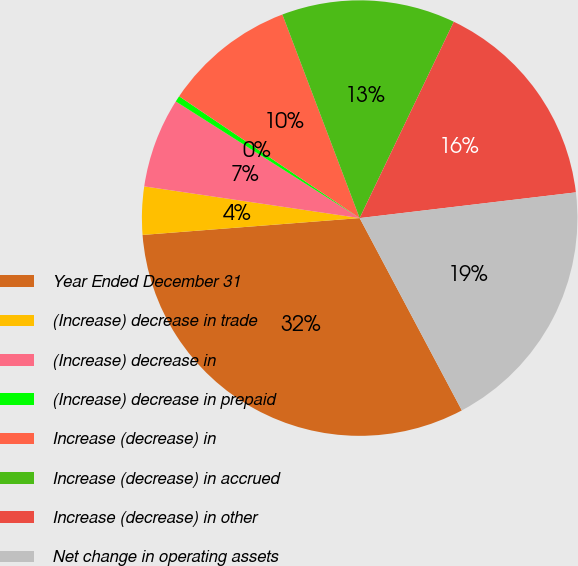Convert chart. <chart><loc_0><loc_0><loc_500><loc_500><pie_chart><fcel>Year Ended December 31<fcel>(Increase) decrease in trade<fcel>(Increase) decrease in<fcel>(Increase) decrease in prepaid<fcel>Increase (decrease) in<fcel>Increase (decrease) in accrued<fcel>Increase (decrease) in other<fcel>Net change in operating assets<nl><fcel>31.54%<fcel>3.56%<fcel>6.67%<fcel>0.45%<fcel>9.78%<fcel>12.89%<fcel>16.0%<fcel>19.11%<nl></chart> 